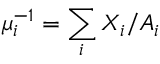Convert formula to latex. <formula><loc_0><loc_0><loc_500><loc_500>\mu _ { i } ^ { - 1 } = \sum _ { i } X _ { i } / A _ { i }</formula> 